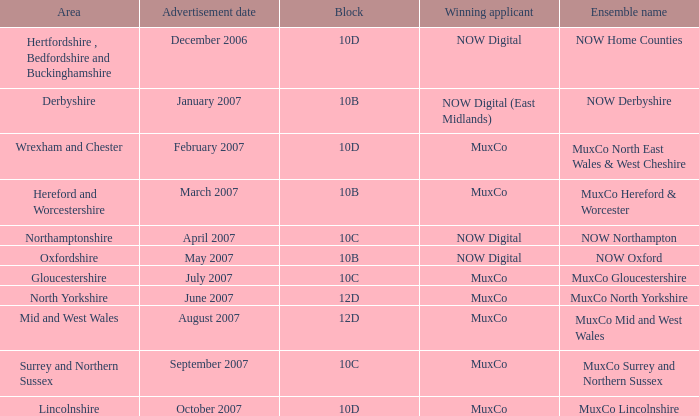What is Ensemble Name Muxco Gloucestershire's Advertisement Date in Block 10C? July 2007. 